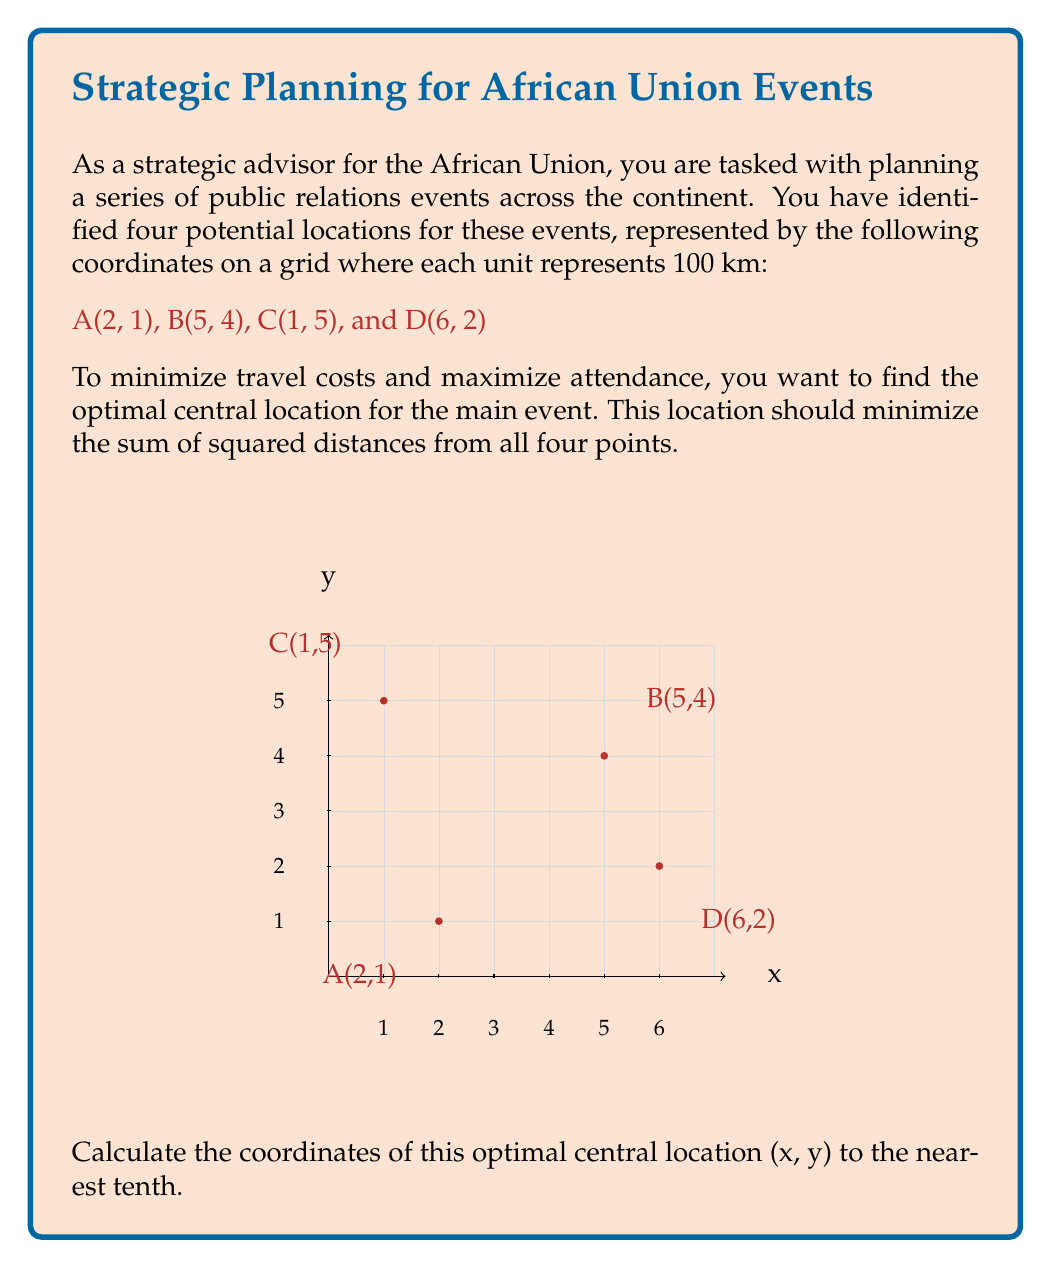Solve this math problem. To find the optimal central location that minimizes the sum of squared distances, we need to calculate the centroid of the given points. The centroid represents the arithmetic mean position of all points in the set.

Step 1: Calculate the x-coordinate of the centroid.
$x = \frac{x_A + x_B + x_C + x_D}{4}$
$x = \frac{2 + 5 + 1 + 6}{4} = \frac{14}{4} = 3.5$

Step 2: Calculate the y-coordinate of the centroid.
$y = \frac{y_A + y_B + y_C + y_D}{4}$
$y = \frac{1 + 4 + 5 + 2}{4} = \frac{12}{4} = 3$

Step 3: Round the coordinates to the nearest tenth.
x = 3.5 (already to the nearest tenth)
y = 3.0

Therefore, the optimal central location for the main event is (3.5, 3.0).

This location minimizes the sum of squared distances because:

1. It balances the pull of all four locations equally.
2. Any movement away from this point would increase the distance to some points more than it decreases the distance to others, resulting in a higher sum of squared distances.

The centroid method is particularly effective for this purpose as it takes into account both the x and y coordinates simultaneously, providing a balanced solution that considers the geographical spread of all event locations.
Answer: (3.5, 3.0) 